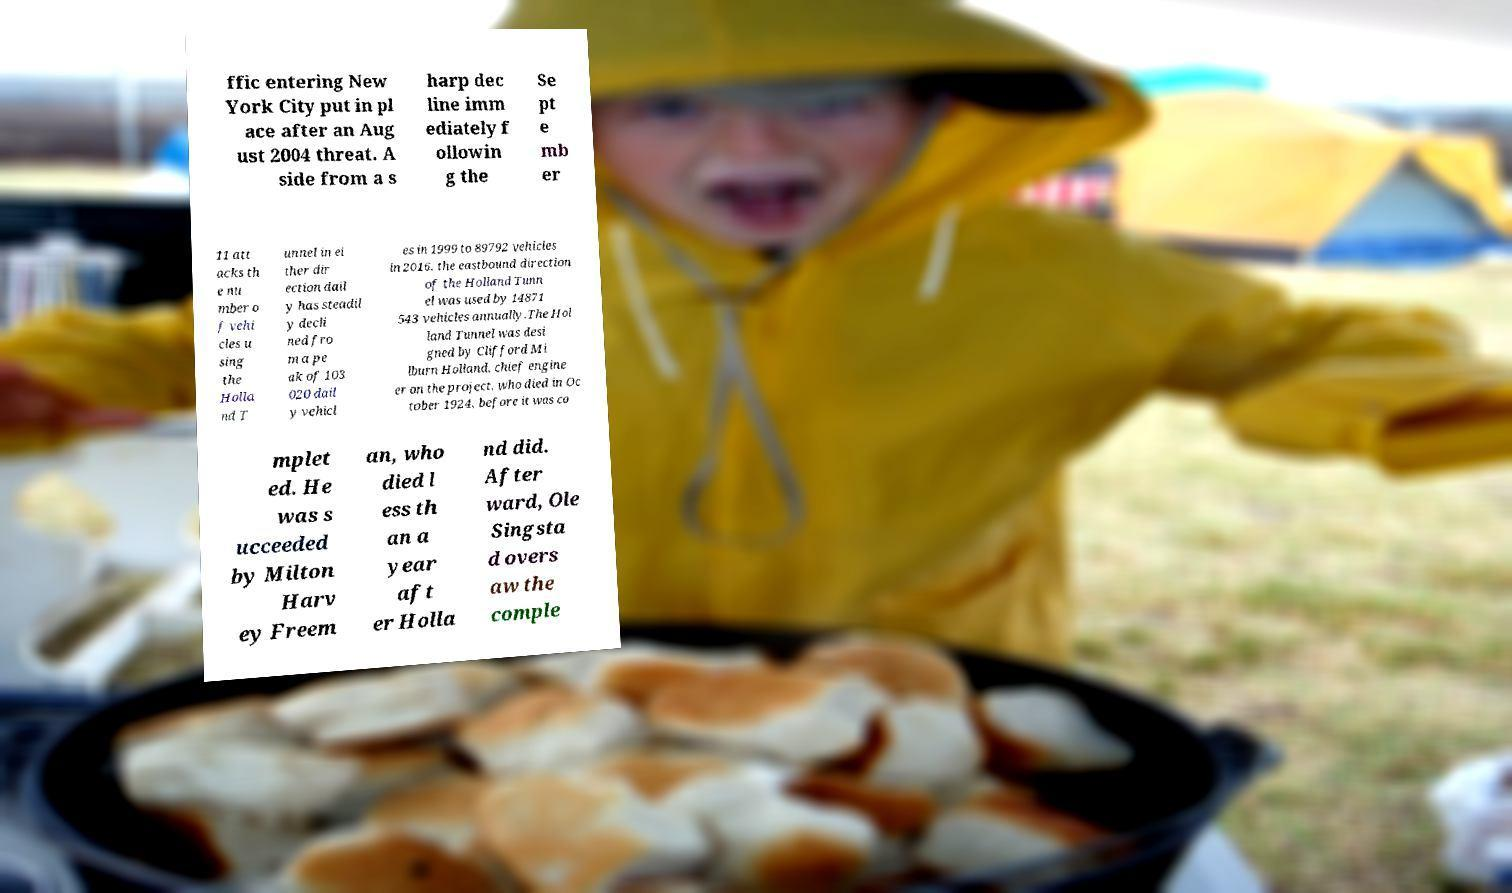Can you read and provide the text displayed in the image?This photo seems to have some interesting text. Can you extract and type it out for me? ffic entering New York City put in pl ace after an Aug ust 2004 threat. A side from a s harp dec line imm ediately f ollowin g the Se pt e mb er 11 att acks th e nu mber o f vehi cles u sing the Holla nd T unnel in ei ther dir ection dail y has steadil y decli ned fro m a pe ak of 103 020 dail y vehicl es in 1999 to 89792 vehicles in 2016. the eastbound direction of the Holland Tunn el was used by 14871 543 vehicles annually.The Hol land Tunnel was desi gned by Clifford Mi lburn Holland, chief engine er on the project, who died in Oc tober 1924, before it was co mplet ed. He was s ucceeded by Milton Harv ey Freem an, who died l ess th an a year aft er Holla nd did. After ward, Ole Singsta d overs aw the comple 